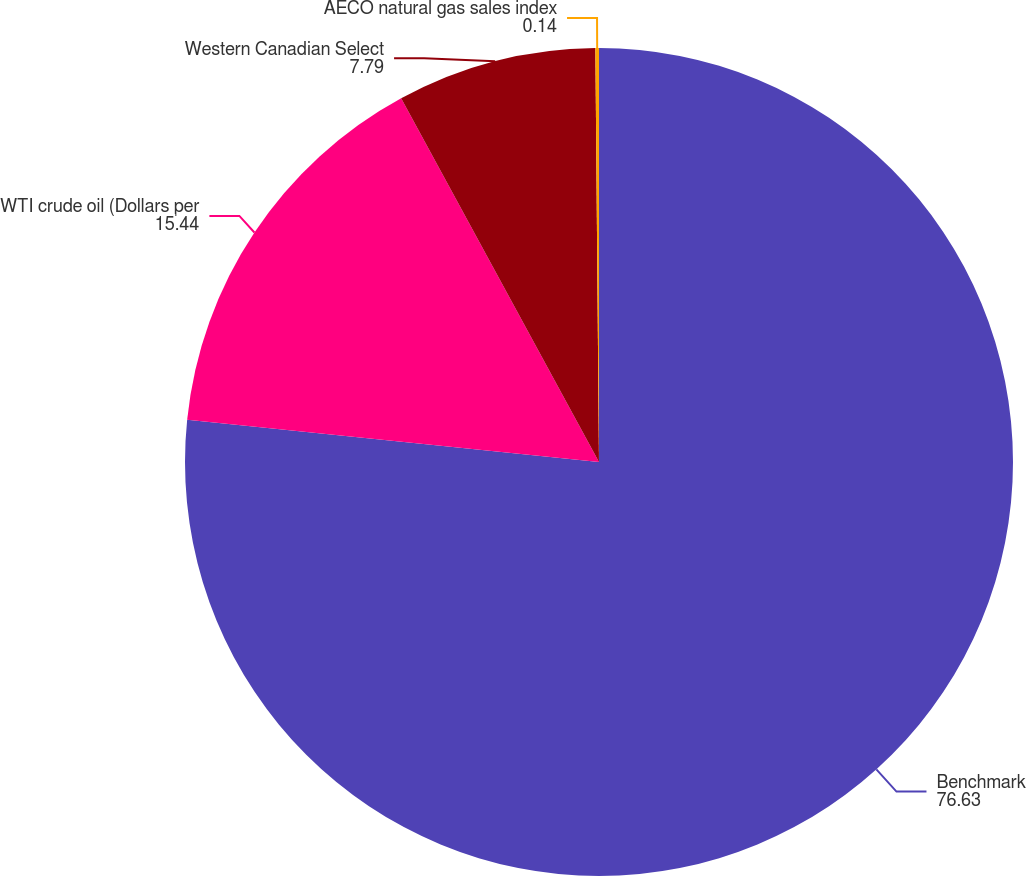<chart> <loc_0><loc_0><loc_500><loc_500><pie_chart><fcel>Benchmark<fcel>WTI crude oil (Dollars per<fcel>Western Canadian Select<fcel>AECO natural gas sales index<nl><fcel>76.63%<fcel>15.44%<fcel>7.79%<fcel>0.14%<nl></chart> 